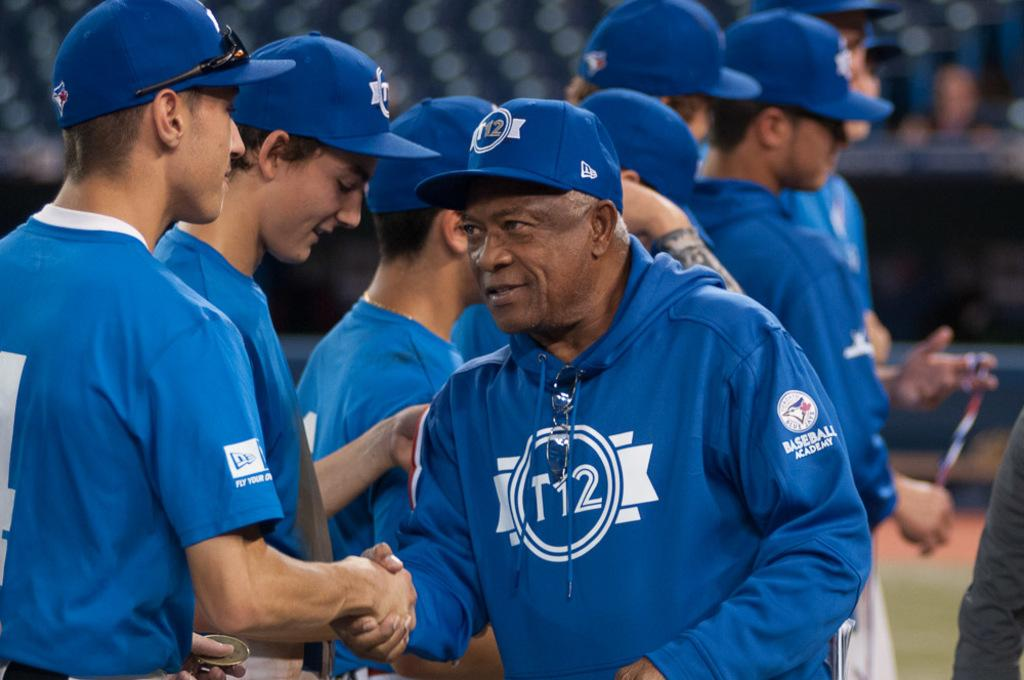<image>
Relay a brief, clear account of the picture shown. A coach with T12 on his sweatshirt shakes someone's hand. 